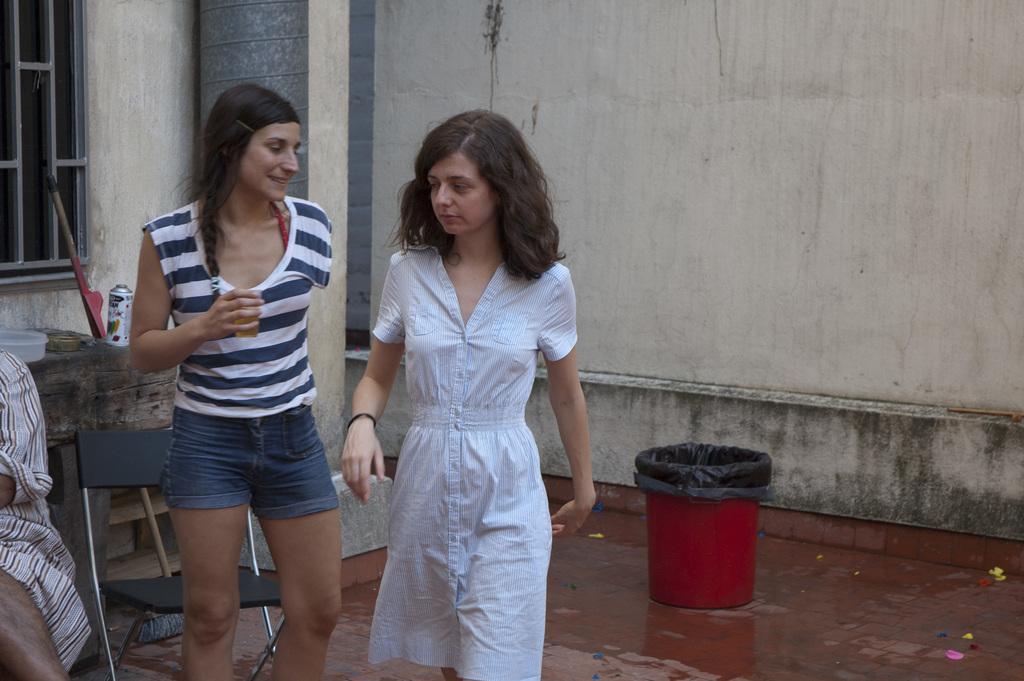In one or two sentences, can you explain what this image depicts? In the background we can see wall, pillar and window. On the table we can see few objects. Here we can see a person sitting on a chair. Near to a chair we can see two women standing. We can see a trash can on the floor. 